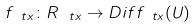Convert formula to latex. <formula><loc_0><loc_0><loc_500><loc_500>f _ { \ t x } \colon R _ { \ t x } \rightarrow D i f f _ { \ t x } ( U )</formula> 